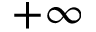Convert formula to latex. <formula><loc_0><loc_0><loc_500><loc_500>+ \infty</formula> 